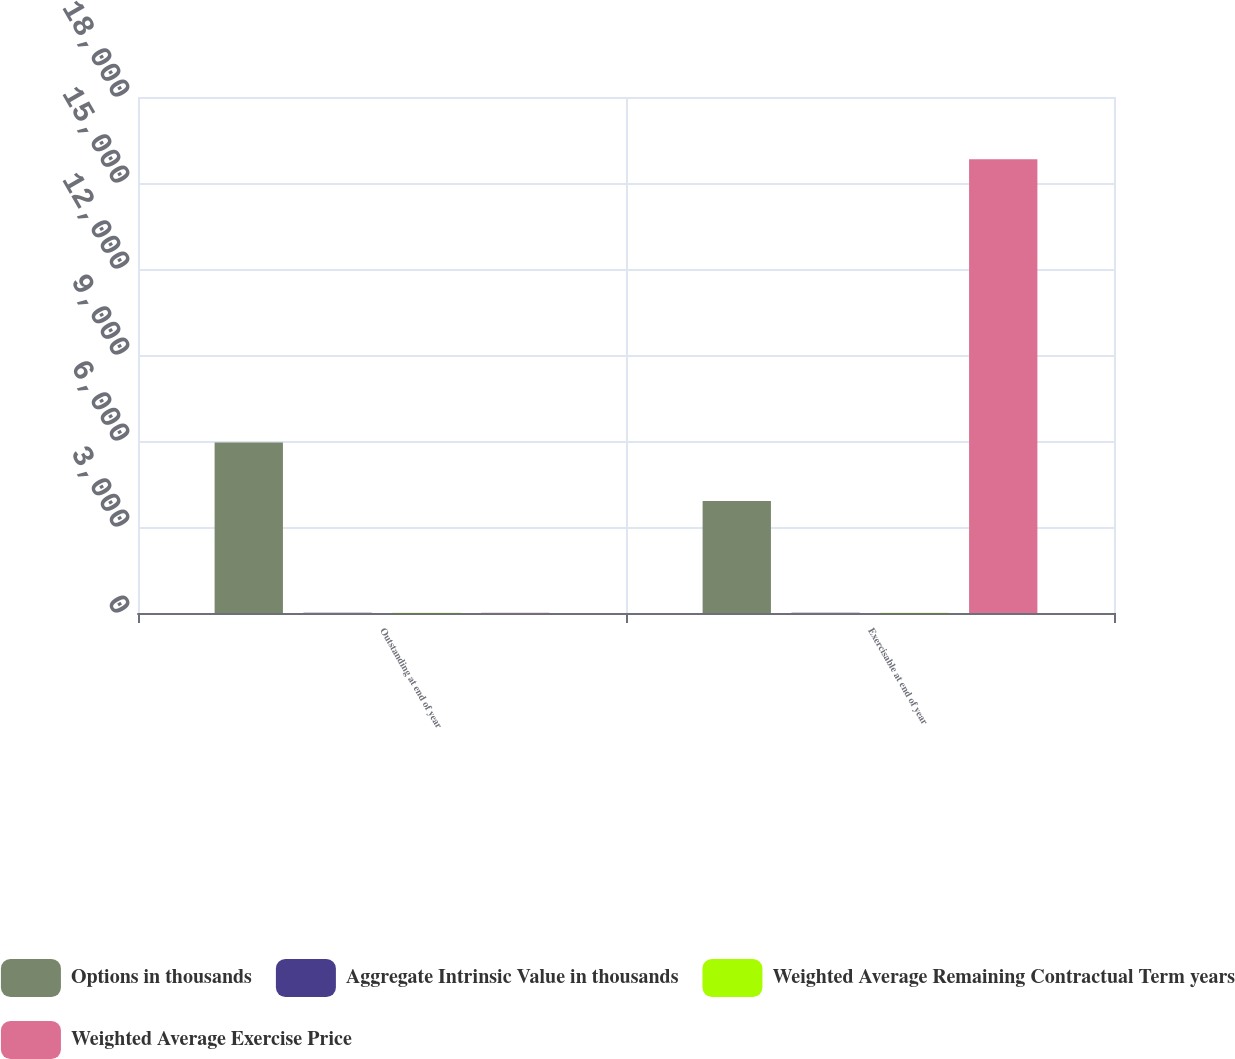<chart> <loc_0><loc_0><loc_500><loc_500><stacked_bar_chart><ecel><fcel>Outstanding at end of year<fcel>Exercisable at end of year<nl><fcel>Options in thousands<fcel>5945<fcel>3910<nl><fcel>Aggregate Intrinsic Value in thousands<fcel>10.27<fcel>10.8<nl><fcel>Weighted Average Remaining Contractual Term years<fcel>6.3<fcel>5.18<nl><fcel>Weighted Average Exercise Price<fcel>10.8<fcel>15829<nl></chart> 